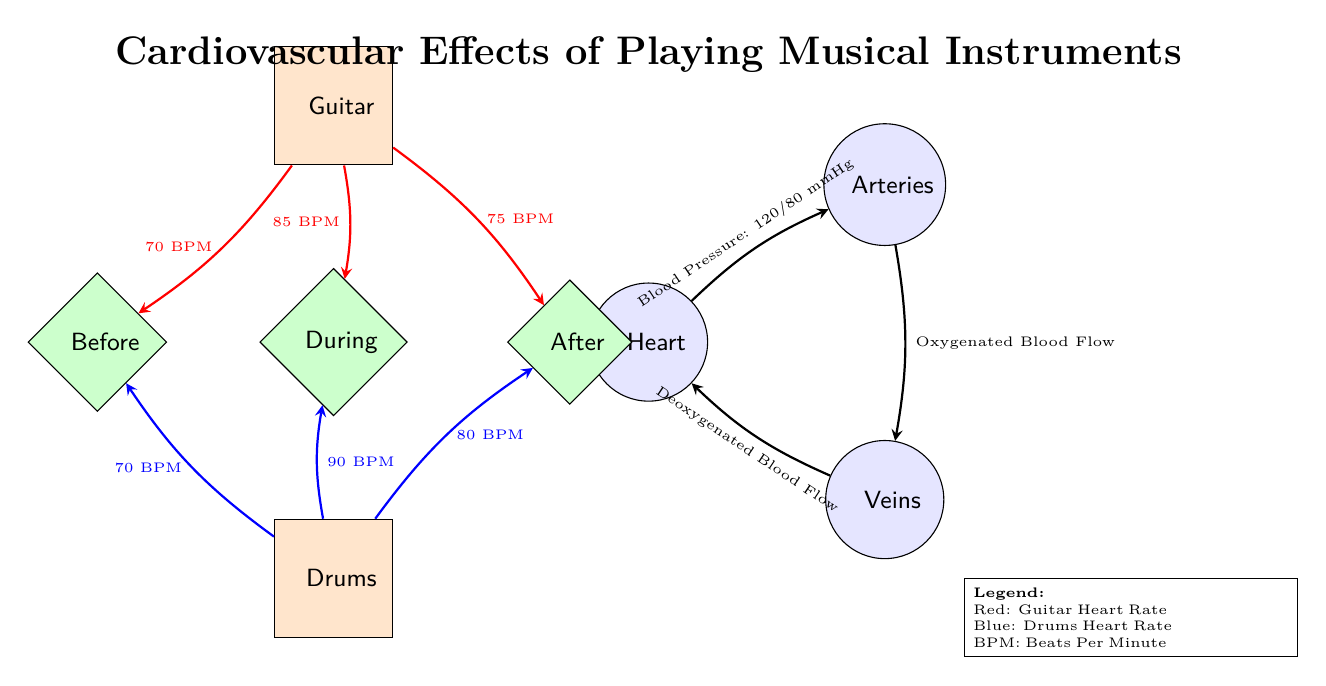What is the blood pressure before playing the guitar? The diagram indicates the blood pressure before playing the guitar is 120/80 mmHg, which is shown on the edge connecting the heart to the arteries labeled with that measurement.
Answer: 120/80 mmHg What is the heart rate while playing the drums? The edge indicating the heart rate during playing the drums shows the value of 90 BPM, which is specifically referenced in the diagram next to the 'During' node connected to the drums.
Answer: 90 BPM How many nodes are in the diagram? The total count of nodes includes the heart, arteries, veins, guitar, drums, and the three phases (before, during, after), which sums to eight nodes in total.
Answer: 8 What is the heart rate after playing the guitar? The heart rate after playing the guitar is indicated as 75 BPM on the edge connecting the 'After' node to the guitar node, clearly stating that specific value.
Answer: 75 BPM Which musical instrument has the highest heart rate during play? Examining the heart rates during play, the drums show a heart rate of 90 BPM, which is higher than the guitar's 85 BPM during play. Thus, the drums have the highest heart rate.
Answer: Drums What is the flow direction of deoxygenated blood? The flow of deoxygenated blood is shown flowing from the veins back to the heart in the diagram, clearly indicated by the arrow that connects the veins to the heart.
Answer: Veins to Heart What is the heart rate before playing the guitar? The diagram specifies that the heart rate before playing the guitar is 70 BPM, which is noted directly on the edge linking the guitar to the 'Before' phase.
Answer: 70 BPM What measurement indicates the oxygenated blood flow? The oxygenated blood flow is referred to on the edge connecting the arteries to the veins, indicating that this is the process through which oxygenated blood travels.
Answer: Oxygenated Blood Flow 